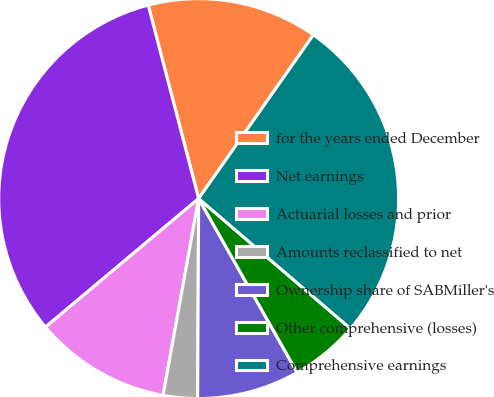Convert chart to OTSL. <chart><loc_0><loc_0><loc_500><loc_500><pie_chart><fcel>for the years ended December<fcel>Net earnings<fcel>Actuarial losses and prior<fcel>Amounts reclassified to net<fcel>Ownership share of SABMiller's<fcel>Other comprehensive (losses)<fcel>Comprehensive earnings<nl><fcel>13.79%<fcel>32.05%<fcel>11.04%<fcel>2.77%<fcel>8.28%<fcel>5.53%<fcel>26.54%<nl></chart> 